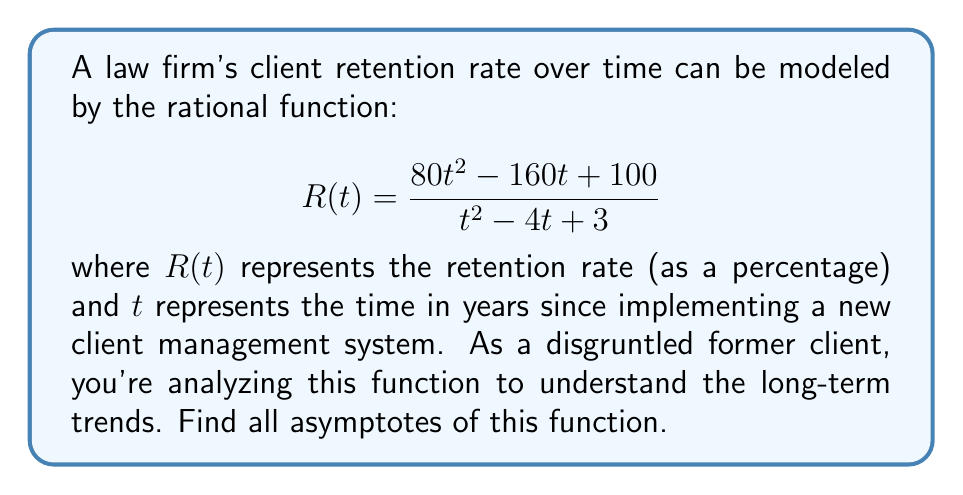Can you solve this math problem? To find the asymptotes, we need to follow these steps:

1) Vertical asymptotes:
   Set the denominator to zero and solve for t:
   $$t^2 - 4t + 3 = 0$$
   $$(t - 1)(t - 3) = 0$$
   $$t = 1 \text{ or } t = 3$$

2) Horizontal asymptote:
   Compare the degrees of the numerator and denominator:
   Degree of numerator = 2
   Degree of denominator = 2
   Since they're equal, divide the leading coefficients:
   $$\lim_{t \to \infty} R(t) = \frac{80}{1} = 80$$

3) Slant asymptote:
   Since the degree of the numerator equals the degree of the denominator, there is no slant asymptote.

Therefore, the function has:
- Vertical asymptotes at $t = 1$ and $t = 3$
- Horizontal asymptote at $y = 80$
Answer: Vertical asymptotes: $t = 1, t = 3$; Horizontal asymptote: $y = 80$ 